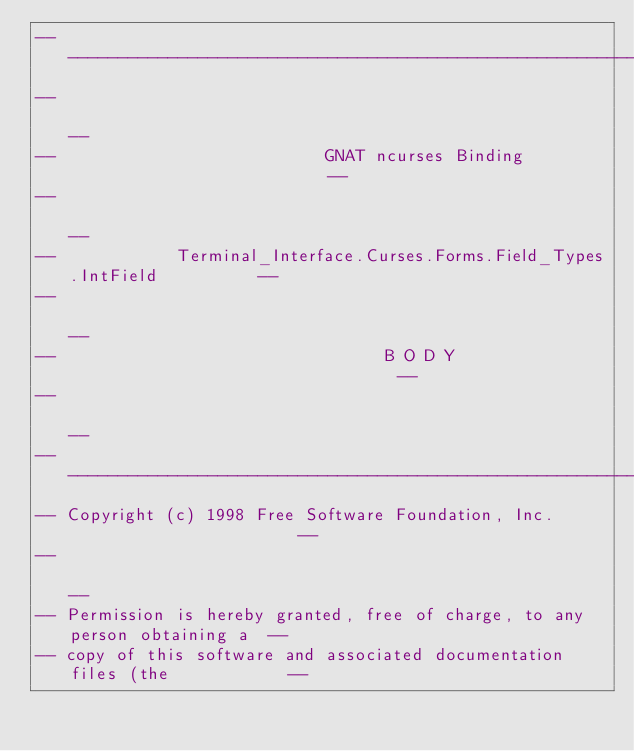Convert code to text. <code><loc_0><loc_0><loc_500><loc_500><_Ada_>------------------------------------------------------------------------------
--                                                                          --
--                           GNAT ncurses Binding                           --
--                                                                          --
--            Terminal_Interface.Curses.Forms.Field_Types.IntField          --
--                                                                          --
--                                 B O D Y                                  --
--                                                                          --
------------------------------------------------------------------------------
-- Copyright (c) 1998 Free Software Foundation, Inc.                        --
--                                                                          --
-- Permission is hereby granted, free of charge, to any person obtaining a  --
-- copy of this software and associated documentation files (the            --</code> 